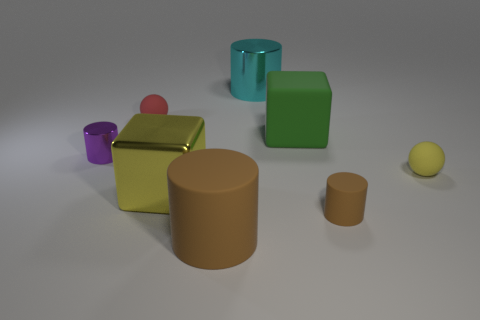There is a purple thing that is the same shape as the cyan metal object; what material is it?
Keep it short and to the point. Metal. What number of rubber balls have the same color as the big shiny cube?
Ensure brevity in your answer.  1. There is a large object that is to the left of the big green cube and behind the purple cylinder; what material is it?
Give a very brief answer. Metal. There is another small matte thing that is the same shape as the red matte object; what color is it?
Make the answer very short. Yellow. How big is the green object?
Provide a short and direct response. Large. What color is the small thing behind the metal cylinder to the left of the large metallic block?
Make the answer very short. Red. What number of objects are on the right side of the large metallic cube and in front of the yellow ball?
Your answer should be very brief. 2. Is the number of tiny purple metallic things greater than the number of tiny purple metal blocks?
Your answer should be very brief. Yes. What is the tiny purple thing made of?
Your answer should be very brief. Metal. There is a tiny cylinder left of the red matte thing; what number of small spheres are in front of it?
Ensure brevity in your answer.  1. 